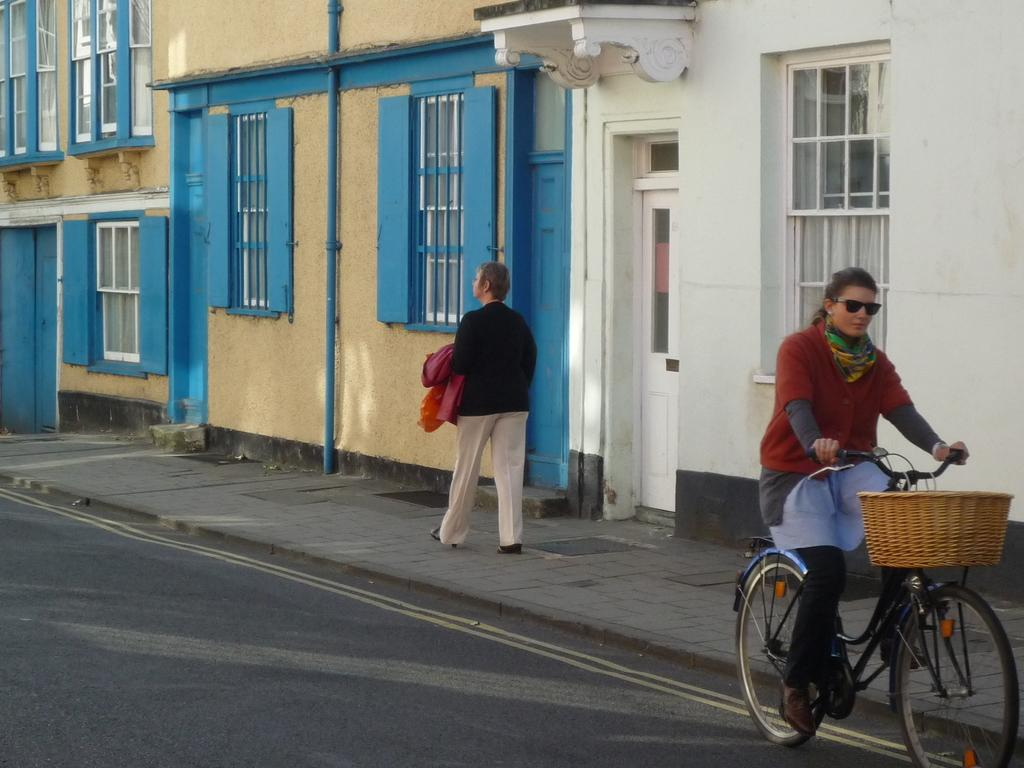What is the woman doing in the image? The woman is riding a bicycle on a road. Where is the woman positioned on the road? The woman is on the right side of the road. What is the other person in the image doing? There is a person walking on the sideway of the road. What type of bird can be seen flying in the image? There is no bird present in the image; it features a woman riding a bicycle and a person walking on the sideway. How does the wind affect the woman riding the bicycle in the image? The image does not provide information about the wind, so we cannot determine its effect on the woman riding the bicycle. 